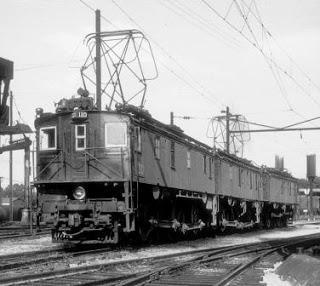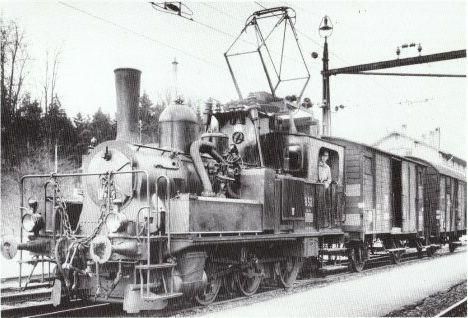The first image is the image on the left, the second image is the image on the right. Considering the images on both sides, is "Two trains are both heading towards the left direction." valid? Answer yes or no. Yes. The first image is the image on the left, the second image is the image on the right. Evaluate the accuracy of this statement regarding the images: "The visible end of the train in the right image has a flat front above a cattle guard.". Is it true? Answer yes or no. No. 